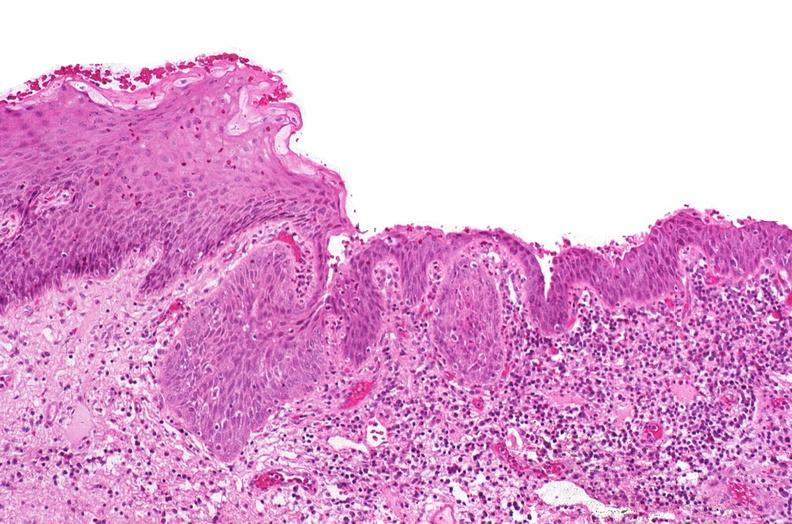what does this image show?
Answer the question using a single word or phrase. Renal pelvis 